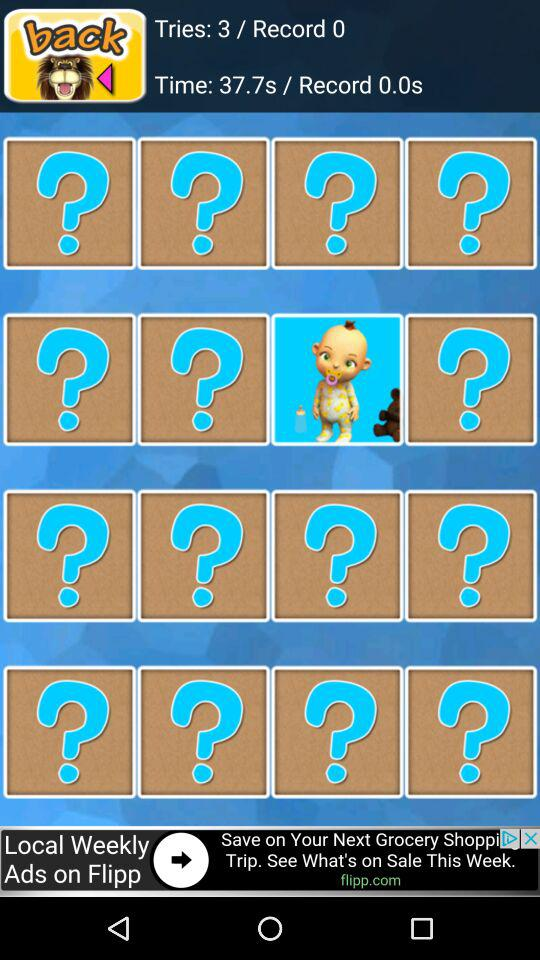What was the recorded time? The recorded time is 37.7 seconds. 